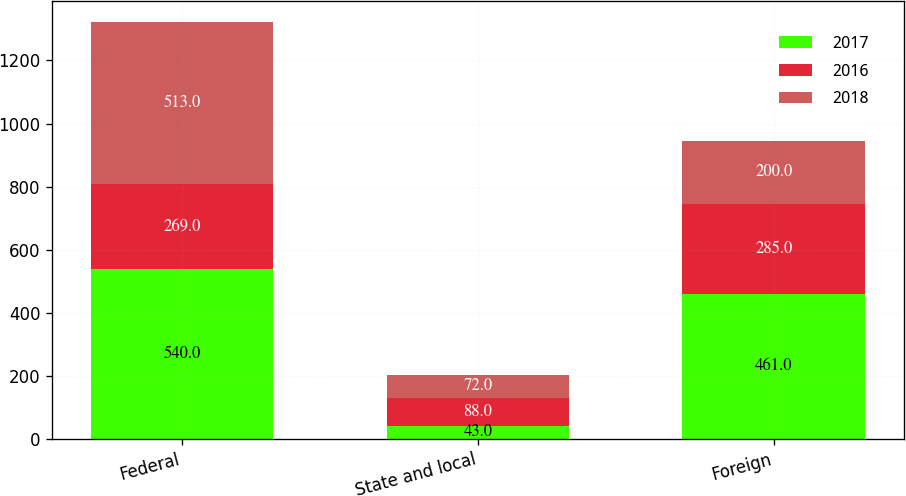<chart> <loc_0><loc_0><loc_500><loc_500><stacked_bar_chart><ecel><fcel>Federal<fcel>State and local<fcel>Foreign<nl><fcel>2017<fcel>540<fcel>43<fcel>461<nl><fcel>2016<fcel>269<fcel>88<fcel>285<nl><fcel>2018<fcel>513<fcel>72<fcel>200<nl></chart> 